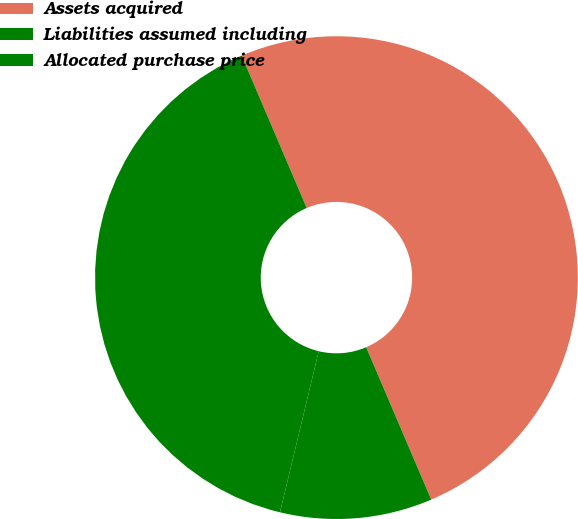Convert chart. <chart><loc_0><loc_0><loc_500><loc_500><pie_chart><fcel>Assets acquired<fcel>Liabilities assumed including<fcel>Allocated purchase price<nl><fcel>50.0%<fcel>39.82%<fcel>10.18%<nl></chart> 